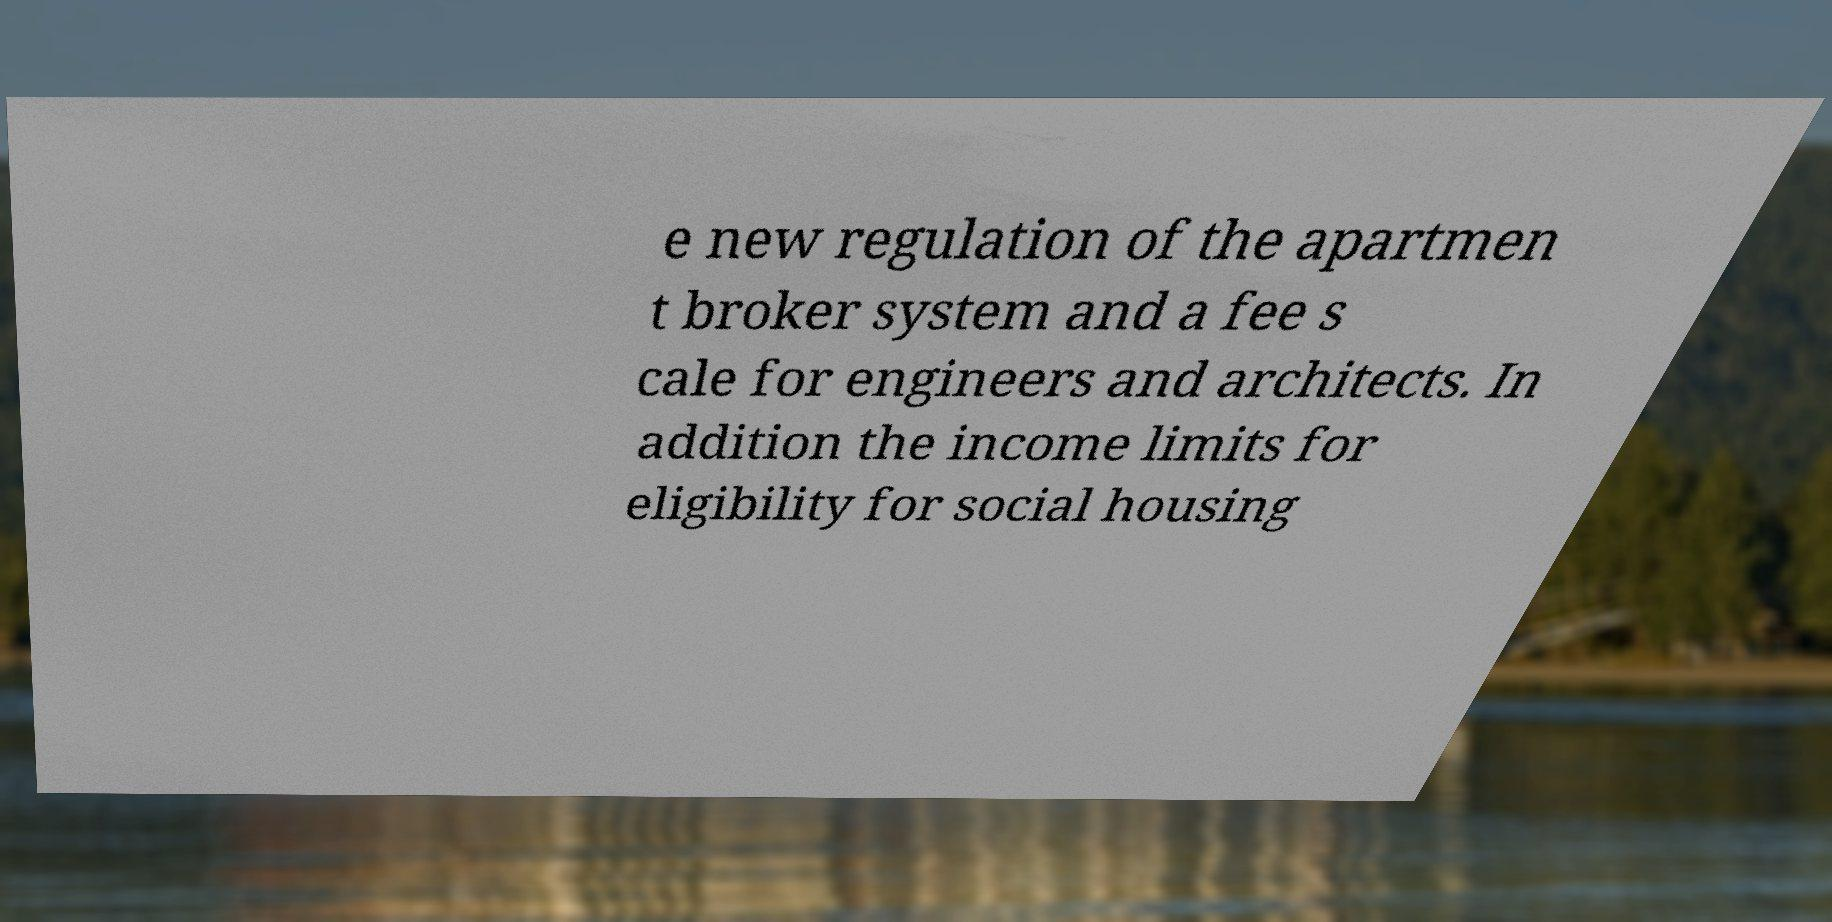For documentation purposes, I need the text within this image transcribed. Could you provide that? e new regulation of the apartmen t broker system and a fee s cale for engineers and architects. In addition the income limits for eligibility for social housing 